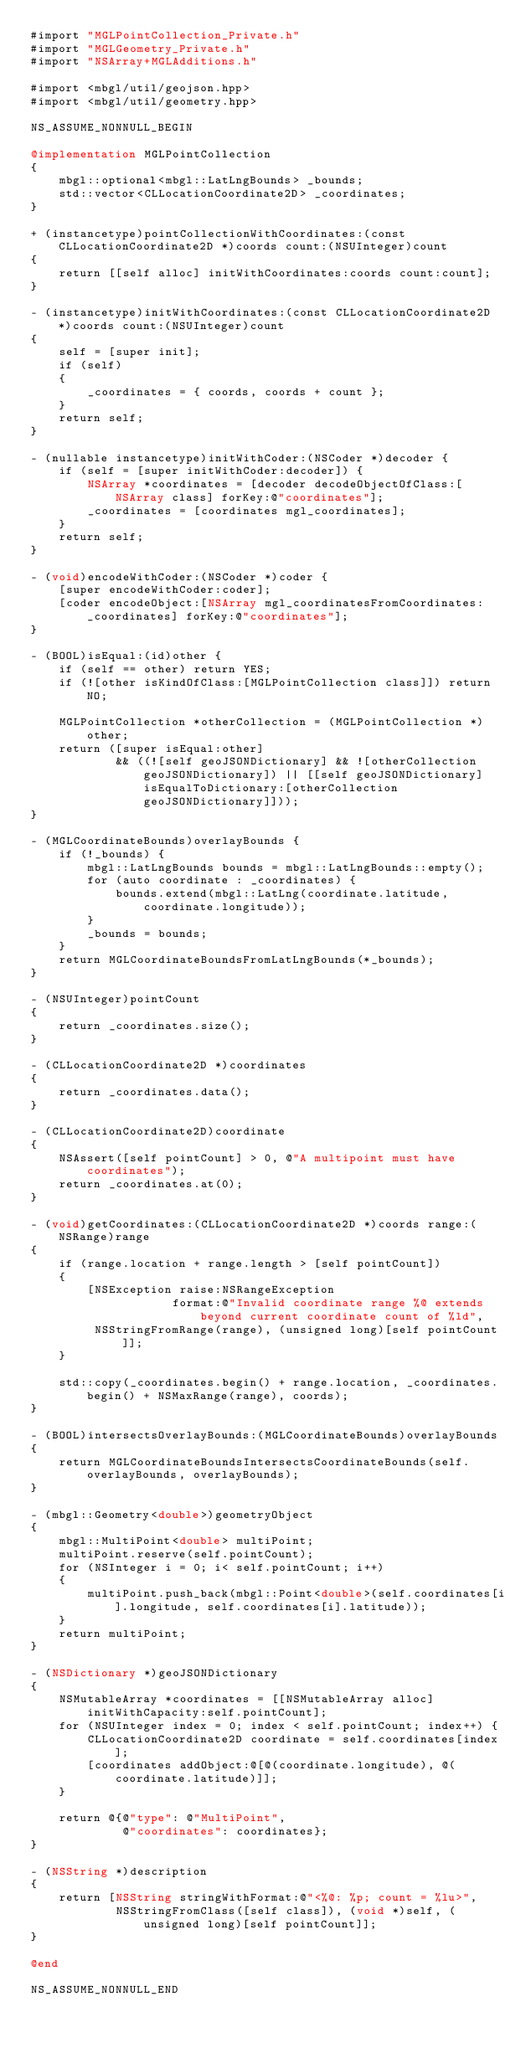Convert code to text. <code><loc_0><loc_0><loc_500><loc_500><_ObjectiveC_>#import "MGLPointCollection_Private.h"
#import "MGLGeometry_Private.h"
#import "NSArray+MGLAdditions.h"

#import <mbgl/util/geojson.hpp>
#import <mbgl/util/geometry.hpp>

NS_ASSUME_NONNULL_BEGIN

@implementation MGLPointCollection
{
    mbgl::optional<mbgl::LatLngBounds> _bounds;
    std::vector<CLLocationCoordinate2D> _coordinates;
}

+ (instancetype)pointCollectionWithCoordinates:(const CLLocationCoordinate2D *)coords count:(NSUInteger)count
{
    return [[self alloc] initWithCoordinates:coords count:count];
}

- (instancetype)initWithCoordinates:(const CLLocationCoordinate2D *)coords count:(NSUInteger)count
{
    self = [super init];
    if (self)
    {
        _coordinates = { coords, coords + count };
    }
    return self;
}

- (nullable instancetype)initWithCoder:(NSCoder *)decoder {
    if (self = [super initWithCoder:decoder]) {
        NSArray *coordinates = [decoder decodeObjectOfClass:[NSArray class] forKey:@"coordinates"];
        _coordinates = [coordinates mgl_coordinates];
    }
    return self;
}

- (void)encodeWithCoder:(NSCoder *)coder {
    [super encodeWithCoder:coder];
    [coder encodeObject:[NSArray mgl_coordinatesFromCoordinates:_coordinates] forKey:@"coordinates"];
}

- (BOOL)isEqual:(id)other {
    if (self == other) return YES;
    if (![other isKindOfClass:[MGLPointCollection class]]) return NO;

    MGLPointCollection *otherCollection = (MGLPointCollection *)other;
    return ([super isEqual:other]
            && ((![self geoJSONDictionary] && ![otherCollection geoJSONDictionary]) || [[self geoJSONDictionary] isEqualToDictionary:[otherCollection geoJSONDictionary]]));
}

- (MGLCoordinateBounds)overlayBounds {
    if (!_bounds) {
        mbgl::LatLngBounds bounds = mbgl::LatLngBounds::empty();
        for (auto coordinate : _coordinates) {
            bounds.extend(mbgl::LatLng(coordinate.latitude, coordinate.longitude));
        }
        _bounds = bounds;
    }
    return MGLCoordinateBoundsFromLatLngBounds(*_bounds);
}

- (NSUInteger)pointCount
{
    return _coordinates.size();
}

- (CLLocationCoordinate2D *)coordinates
{
    return _coordinates.data();
}

- (CLLocationCoordinate2D)coordinate
{
    NSAssert([self pointCount] > 0, @"A multipoint must have coordinates");
    return _coordinates.at(0);
}

- (void)getCoordinates:(CLLocationCoordinate2D *)coords range:(NSRange)range
{
    if (range.location + range.length > [self pointCount])
    {
        [NSException raise:NSRangeException
                    format:@"Invalid coordinate range %@ extends beyond current coordinate count of %ld",
         NSStringFromRange(range), (unsigned long)[self pointCount]];
    }

    std::copy(_coordinates.begin() + range.location, _coordinates.begin() + NSMaxRange(range), coords);
}

- (BOOL)intersectsOverlayBounds:(MGLCoordinateBounds)overlayBounds
{
    return MGLCoordinateBoundsIntersectsCoordinateBounds(self.overlayBounds, overlayBounds);
}

- (mbgl::Geometry<double>)geometryObject
{
    mbgl::MultiPoint<double> multiPoint;
    multiPoint.reserve(self.pointCount);
    for (NSInteger i = 0; i< self.pointCount; i++)
    {
        multiPoint.push_back(mbgl::Point<double>(self.coordinates[i].longitude, self.coordinates[i].latitude));
    }
    return multiPoint;
}

- (NSDictionary *)geoJSONDictionary
{
    NSMutableArray *coordinates = [[NSMutableArray alloc] initWithCapacity:self.pointCount];
    for (NSUInteger index = 0; index < self.pointCount; index++) {
        CLLocationCoordinate2D coordinate = self.coordinates[index];
        [coordinates addObject:@[@(coordinate.longitude), @(coordinate.latitude)]];
    }

    return @{@"type": @"MultiPoint",
             @"coordinates": coordinates};
}

- (NSString *)description
{
    return [NSString stringWithFormat:@"<%@: %p; count = %lu>",
            NSStringFromClass([self class]), (void *)self, (unsigned long)[self pointCount]];
}

@end

NS_ASSUME_NONNULL_END
</code> 